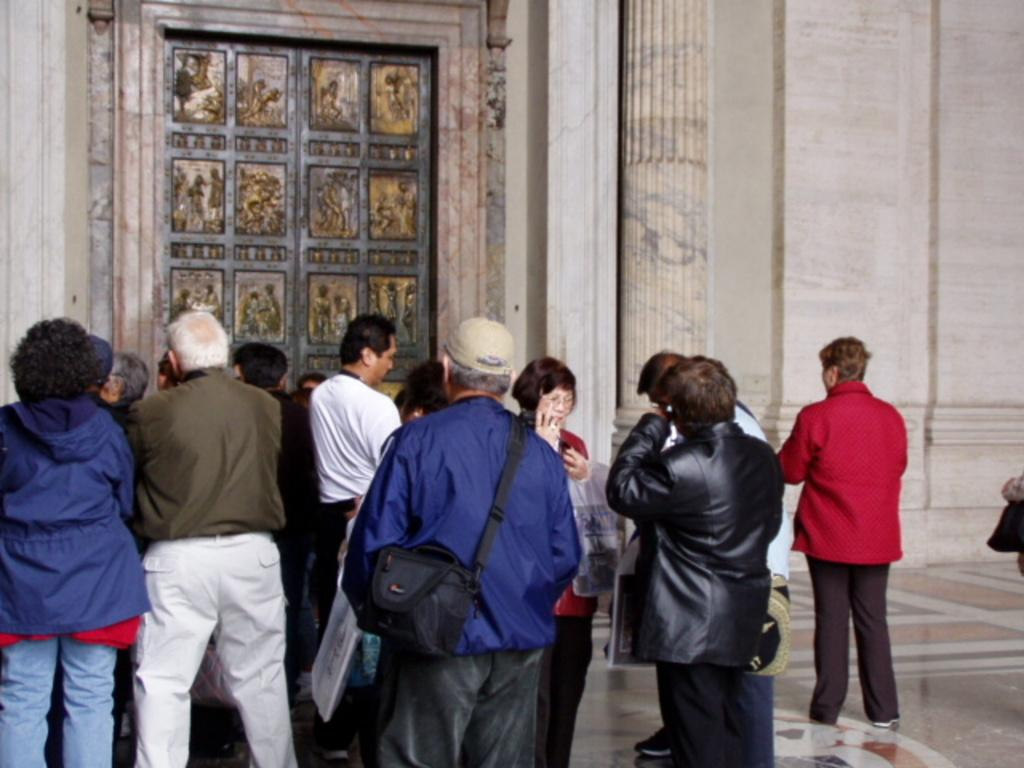What can be seen in the image? There are people standing in the image. What structure is visible in the image? There is a door visible in the image. What type of haircut does the crook have in the image? There is no crook or haircut mentioned in the image; it only shows people standing and a door. 